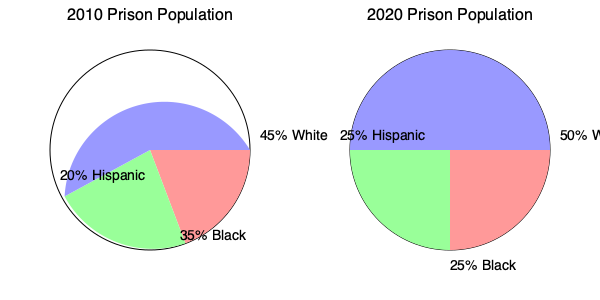Based on the pie charts showing prison population demographics in 2010 and 2020, which racial group experienced the most significant percentage decrease in representation? To determine which racial group experienced the most significant percentage decrease in representation from 2010 to 2020, we need to compare the percentages for each group across both years:

1. White population:
   2010: 45%
   2020: 50%
   Change: +5% (increase)

2. Black population:
   2010: 35%
   2020: 25%
   Change: -10% (decrease)

3. Hispanic population:
   2010: 20%
   2020: 25%
   Change: +5% (increase)

The Black population is the only group that experienced a decrease, going from 35% to 25%, which is a 10 percentage point reduction. Both White and Hispanic populations increased by 5 percentage points each.

Therefore, the racial group that experienced the most significant percentage decrease in representation is the Black population.
Answer: Black population 